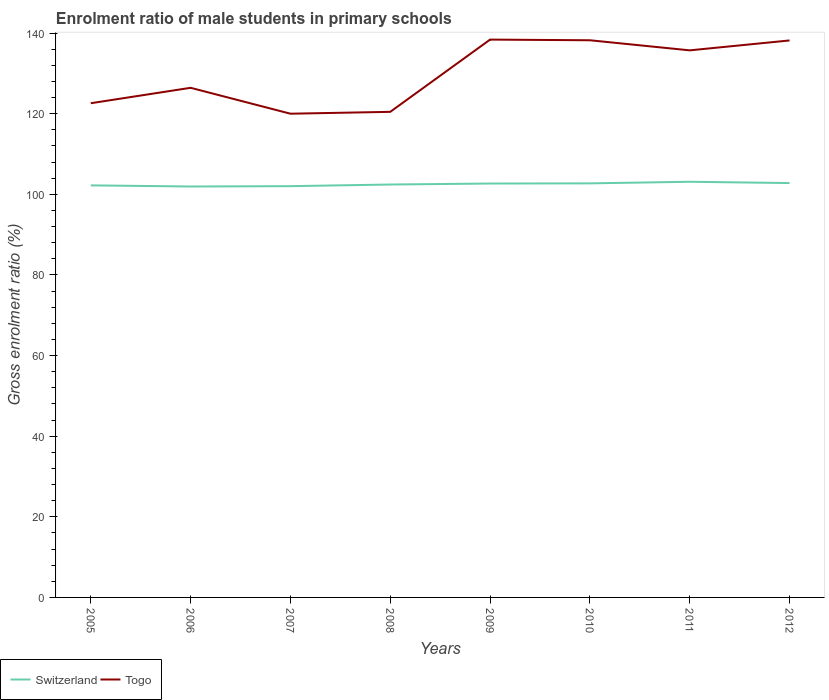How many different coloured lines are there?
Your answer should be very brief. 2. Does the line corresponding to Switzerland intersect with the line corresponding to Togo?
Your answer should be very brief. No. Across all years, what is the maximum enrolment ratio of male students in primary schools in Togo?
Your answer should be very brief. 120. What is the total enrolment ratio of male students in primary schools in Switzerland in the graph?
Make the answer very short. -0.68. What is the difference between the highest and the second highest enrolment ratio of male students in primary schools in Switzerland?
Give a very brief answer. 1.17. Is the enrolment ratio of male students in primary schools in Switzerland strictly greater than the enrolment ratio of male students in primary schools in Togo over the years?
Your answer should be compact. Yes. How many years are there in the graph?
Your answer should be compact. 8. Does the graph contain any zero values?
Your answer should be compact. No. Does the graph contain grids?
Ensure brevity in your answer.  No. How many legend labels are there?
Your answer should be very brief. 2. How are the legend labels stacked?
Give a very brief answer. Horizontal. What is the title of the graph?
Give a very brief answer. Enrolment ratio of male students in primary schools. Does "Marshall Islands" appear as one of the legend labels in the graph?
Ensure brevity in your answer.  No. What is the Gross enrolment ratio (%) of Switzerland in 2005?
Your answer should be very brief. 102.22. What is the Gross enrolment ratio (%) in Togo in 2005?
Your answer should be very brief. 122.6. What is the Gross enrolment ratio (%) of Switzerland in 2006?
Make the answer very short. 101.94. What is the Gross enrolment ratio (%) in Togo in 2006?
Offer a very short reply. 126.42. What is the Gross enrolment ratio (%) in Switzerland in 2007?
Offer a very short reply. 102.03. What is the Gross enrolment ratio (%) in Togo in 2007?
Ensure brevity in your answer.  120. What is the Gross enrolment ratio (%) in Switzerland in 2008?
Your answer should be very brief. 102.43. What is the Gross enrolment ratio (%) in Togo in 2008?
Your response must be concise. 120.46. What is the Gross enrolment ratio (%) of Switzerland in 2009?
Provide a succinct answer. 102.68. What is the Gross enrolment ratio (%) of Togo in 2009?
Keep it short and to the point. 138.38. What is the Gross enrolment ratio (%) in Switzerland in 2010?
Your response must be concise. 102.72. What is the Gross enrolment ratio (%) in Togo in 2010?
Make the answer very short. 138.22. What is the Gross enrolment ratio (%) in Switzerland in 2011?
Keep it short and to the point. 103.12. What is the Gross enrolment ratio (%) of Togo in 2011?
Make the answer very short. 135.72. What is the Gross enrolment ratio (%) of Switzerland in 2012?
Offer a terse response. 102.79. What is the Gross enrolment ratio (%) of Togo in 2012?
Provide a short and direct response. 138.17. Across all years, what is the maximum Gross enrolment ratio (%) in Switzerland?
Provide a succinct answer. 103.12. Across all years, what is the maximum Gross enrolment ratio (%) of Togo?
Give a very brief answer. 138.38. Across all years, what is the minimum Gross enrolment ratio (%) of Switzerland?
Ensure brevity in your answer.  101.94. Across all years, what is the minimum Gross enrolment ratio (%) in Togo?
Give a very brief answer. 120. What is the total Gross enrolment ratio (%) in Switzerland in the graph?
Keep it short and to the point. 819.93. What is the total Gross enrolment ratio (%) in Togo in the graph?
Keep it short and to the point. 1039.98. What is the difference between the Gross enrolment ratio (%) in Switzerland in 2005 and that in 2006?
Your answer should be compact. 0.28. What is the difference between the Gross enrolment ratio (%) in Togo in 2005 and that in 2006?
Offer a very short reply. -3.83. What is the difference between the Gross enrolment ratio (%) in Switzerland in 2005 and that in 2007?
Give a very brief answer. 0.2. What is the difference between the Gross enrolment ratio (%) of Togo in 2005 and that in 2007?
Keep it short and to the point. 2.6. What is the difference between the Gross enrolment ratio (%) in Switzerland in 2005 and that in 2008?
Ensure brevity in your answer.  -0.21. What is the difference between the Gross enrolment ratio (%) of Togo in 2005 and that in 2008?
Your answer should be very brief. 2.14. What is the difference between the Gross enrolment ratio (%) of Switzerland in 2005 and that in 2009?
Offer a terse response. -0.45. What is the difference between the Gross enrolment ratio (%) in Togo in 2005 and that in 2009?
Your response must be concise. -15.79. What is the difference between the Gross enrolment ratio (%) of Switzerland in 2005 and that in 2010?
Your answer should be compact. -0.5. What is the difference between the Gross enrolment ratio (%) in Togo in 2005 and that in 2010?
Make the answer very short. -15.62. What is the difference between the Gross enrolment ratio (%) of Switzerland in 2005 and that in 2011?
Your answer should be compact. -0.9. What is the difference between the Gross enrolment ratio (%) of Togo in 2005 and that in 2011?
Keep it short and to the point. -13.12. What is the difference between the Gross enrolment ratio (%) in Switzerland in 2005 and that in 2012?
Your answer should be compact. -0.57. What is the difference between the Gross enrolment ratio (%) in Togo in 2005 and that in 2012?
Your answer should be very brief. -15.58. What is the difference between the Gross enrolment ratio (%) in Switzerland in 2006 and that in 2007?
Keep it short and to the point. -0.08. What is the difference between the Gross enrolment ratio (%) in Togo in 2006 and that in 2007?
Provide a short and direct response. 6.42. What is the difference between the Gross enrolment ratio (%) in Switzerland in 2006 and that in 2008?
Keep it short and to the point. -0.49. What is the difference between the Gross enrolment ratio (%) of Togo in 2006 and that in 2008?
Your answer should be very brief. 5.96. What is the difference between the Gross enrolment ratio (%) of Switzerland in 2006 and that in 2009?
Provide a succinct answer. -0.73. What is the difference between the Gross enrolment ratio (%) of Togo in 2006 and that in 2009?
Keep it short and to the point. -11.96. What is the difference between the Gross enrolment ratio (%) of Switzerland in 2006 and that in 2010?
Provide a short and direct response. -0.78. What is the difference between the Gross enrolment ratio (%) in Togo in 2006 and that in 2010?
Ensure brevity in your answer.  -11.79. What is the difference between the Gross enrolment ratio (%) of Switzerland in 2006 and that in 2011?
Provide a short and direct response. -1.17. What is the difference between the Gross enrolment ratio (%) of Togo in 2006 and that in 2011?
Offer a terse response. -9.29. What is the difference between the Gross enrolment ratio (%) in Switzerland in 2006 and that in 2012?
Your answer should be very brief. -0.85. What is the difference between the Gross enrolment ratio (%) of Togo in 2006 and that in 2012?
Your answer should be very brief. -11.75. What is the difference between the Gross enrolment ratio (%) of Switzerland in 2007 and that in 2008?
Your answer should be compact. -0.41. What is the difference between the Gross enrolment ratio (%) of Togo in 2007 and that in 2008?
Ensure brevity in your answer.  -0.46. What is the difference between the Gross enrolment ratio (%) in Switzerland in 2007 and that in 2009?
Keep it short and to the point. -0.65. What is the difference between the Gross enrolment ratio (%) in Togo in 2007 and that in 2009?
Offer a very short reply. -18.38. What is the difference between the Gross enrolment ratio (%) in Switzerland in 2007 and that in 2010?
Your answer should be very brief. -0.69. What is the difference between the Gross enrolment ratio (%) of Togo in 2007 and that in 2010?
Offer a terse response. -18.22. What is the difference between the Gross enrolment ratio (%) in Switzerland in 2007 and that in 2011?
Make the answer very short. -1.09. What is the difference between the Gross enrolment ratio (%) in Togo in 2007 and that in 2011?
Ensure brevity in your answer.  -15.72. What is the difference between the Gross enrolment ratio (%) in Switzerland in 2007 and that in 2012?
Ensure brevity in your answer.  -0.77. What is the difference between the Gross enrolment ratio (%) of Togo in 2007 and that in 2012?
Offer a very short reply. -18.17. What is the difference between the Gross enrolment ratio (%) of Switzerland in 2008 and that in 2009?
Ensure brevity in your answer.  -0.24. What is the difference between the Gross enrolment ratio (%) in Togo in 2008 and that in 2009?
Provide a short and direct response. -17.92. What is the difference between the Gross enrolment ratio (%) of Switzerland in 2008 and that in 2010?
Offer a terse response. -0.29. What is the difference between the Gross enrolment ratio (%) of Togo in 2008 and that in 2010?
Your answer should be very brief. -17.76. What is the difference between the Gross enrolment ratio (%) of Switzerland in 2008 and that in 2011?
Keep it short and to the point. -0.68. What is the difference between the Gross enrolment ratio (%) in Togo in 2008 and that in 2011?
Offer a very short reply. -15.25. What is the difference between the Gross enrolment ratio (%) of Switzerland in 2008 and that in 2012?
Make the answer very short. -0.36. What is the difference between the Gross enrolment ratio (%) of Togo in 2008 and that in 2012?
Your answer should be compact. -17.71. What is the difference between the Gross enrolment ratio (%) in Switzerland in 2009 and that in 2010?
Provide a short and direct response. -0.04. What is the difference between the Gross enrolment ratio (%) in Togo in 2009 and that in 2010?
Your response must be concise. 0.17. What is the difference between the Gross enrolment ratio (%) of Switzerland in 2009 and that in 2011?
Keep it short and to the point. -0.44. What is the difference between the Gross enrolment ratio (%) of Togo in 2009 and that in 2011?
Offer a terse response. 2.67. What is the difference between the Gross enrolment ratio (%) of Switzerland in 2009 and that in 2012?
Provide a succinct answer. -0.12. What is the difference between the Gross enrolment ratio (%) in Togo in 2009 and that in 2012?
Keep it short and to the point. 0.21. What is the difference between the Gross enrolment ratio (%) in Switzerland in 2010 and that in 2011?
Offer a very short reply. -0.4. What is the difference between the Gross enrolment ratio (%) of Togo in 2010 and that in 2011?
Your answer should be compact. 2.5. What is the difference between the Gross enrolment ratio (%) of Switzerland in 2010 and that in 2012?
Your response must be concise. -0.08. What is the difference between the Gross enrolment ratio (%) in Togo in 2010 and that in 2012?
Provide a succinct answer. 0.04. What is the difference between the Gross enrolment ratio (%) in Switzerland in 2011 and that in 2012?
Keep it short and to the point. 0.32. What is the difference between the Gross enrolment ratio (%) of Togo in 2011 and that in 2012?
Your response must be concise. -2.46. What is the difference between the Gross enrolment ratio (%) of Switzerland in 2005 and the Gross enrolment ratio (%) of Togo in 2006?
Make the answer very short. -24.2. What is the difference between the Gross enrolment ratio (%) of Switzerland in 2005 and the Gross enrolment ratio (%) of Togo in 2007?
Your response must be concise. -17.78. What is the difference between the Gross enrolment ratio (%) of Switzerland in 2005 and the Gross enrolment ratio (%) of Togo in 2008?
Offer a very short reply. -18.24. What is the difference between the Gross enrolment ratio (%) of Switzerland in 2005 and the Gross enrolment ratio (%) of Togo in 2009?
Give a very brief answer. -36.16. What is the difference between the Gross enrolment ratio (%) of Switzerland in 2005 and the Gross enrolment ratio (%) of Togo in 2010?
Provide a succinct answer. -36. What is the difference between the Gross enrolment ratio (%) of Switzerland in 2005 and the Gross enrolment ratio (%) of Togo in 2011?
Make the answer very short. -33.49. What is the difference between the Gross enrolment ratio (%) in Switzerland in 2005 and the Gross enrolment ratio (%) in Togo in 2012?
Offer a very short reply. -35.95. What is the difference between the Gross enrolment ratio (%) of Switzerland in 2006 and the Gross enrolment ratio (%) of Togo in 2007?
Your answer should be very brief. -18.06. What is the difference between the Gross enrolment ratio (%) in Switzerland in 2006 and the Gross enrolment ratio (%) in Togo in 2008?
Provide a succinct answer. -18.52. What is the difference between the Gross enrolment ratio (%) of Switzerland in 2006 and the Gross enrolment ratio (%) of Togo in 2009?
Give a very brief answer. -36.44. What is the difference between the Gross enrolment ratio (%) of Switzerland in 2006 and the Gross enrolment ratio (%) of Togo in 2010?
Your response must be concise. -36.28. What is the difference between the Gross enrolment ratio (%) of Switzerland in 2006 and the Gross enrolment ratio (%) of Togo in 2011?
Keep it short and to the point. -33.77. What is the difference between the Gross enrolment ratio (%) in Switzerland in 2006 and the Gross enrolment ratio (%) in Togo in 2012?
Ensure brevity in your answer.  -36.23. What is the difference between the Gross enrolment ratio (%) in Switzerland in 2007 and the Gross enrolment ratio (%) in Togo in 2008?
Provide a succinct answer. -18.44. What is the difference between the Gross enrolment ratio (%) of Switzerland in 2007 and the Gross enrolment ratio (%) of Togo in 2009?
Provide a short and direct response. -36.36. What is the difference between the Gross enrolment ratio (%) in Switzerland in 2007 and the Gross enrolment ratio (%) in Togo in 2010?
Offer a terse response. -36.19. What is the difference between the Gross enrolment ratio (%) in Switzerland in 2007 and the Gross enrolment ratio (%) in Togo in 2011?
Provide a short and direct response. -33.69. What is the difference between the Gross enrolment ratio (%) of Switzerland in 2007 and the Gross enrolment ratio (%) of Togo in 2012?
Make the answer very short. -36.15. What is the difference between the Gross enrolment ratio (%) of Switzerland in 2008 and the Gross enrolment ratio (%) of Togo in 2009?
Offer a very short reply. -35.95. What is the difference between the Gross enrolment ratio (%) of Switzerland in 2008 and the Gross enrolment ratio (%) of Togo in 2010?
Offer a very short reply. -35.79. What is the difference between the Gross enrolment ratio (%) of Switzerland in 2008 and the Gross enrolment ratio (%) of Togo in 2011?
Offer a terse response. -33.28. What is the difference between the Gross enrolment ratio (%) in Switzerland in 2008 and the Gross enrolment ratio (%) in Togo in 2012?
Keep it short and to the point. -35.74. What is the difference between the Gross enrolment ratio (%) in Switzerland in 2009 and the Gross enrolment ratio (%) in Togo in 2010?
Ensure brevity in your answer.  -35.54. What is the difference between the Gross enrolment ratio (%) in Switzerland in 2009 and the Gross enrolment ratio (%) in Togo in 2011?
Keep it short and to the point. -33.04. What is the difference between the Gross enrolment ratio (%) of Switzerland in 2009 and the Gross enrolment ratio (%) of Togo in 2012?
Ensure brevity in your answer.  -35.5. What is the difference between the Gross enrolment ratio (%) of Switzerland in 2010 and the Gross enrolment ratio (%) of Togo in 2011?
Offer a terse response. -33. What is the difference between the Gross enrolment ratio (%) in Switzerland in 2010 and the Gross enrolment ratio (%) in Togo in 2012?
Give a very brief answer. -35.45. What is the difference between the Gross enrolment ratio (%) in Switzerland in 2011 and the Gross enrolment ratio (%) in Togo in 2012?
Offer a very short reply. -35.06. What is the average Gross enrolment ratio (%) in Switzerland per year?
Your answer should be compact. 102.49. What is the average Gross enrolment ratio (%) of Togo per year?
Your response must be concise. 130. In the year 2005, what is the difference between the Gross enrolment ratio (%) of Switzerland and Gross enrolment ratio (%) of Togo?
Keep it short and to the point. -20.38. In the year 2006, what is the difference between the Gross enrolment ratio (%) of Switzerland and Gross enrolment ratio (%) of Togo?
Offer a terse response. -24.48. In the year 2007, what is the difference between the Gross enrolment ratio (%) in Switzerland and Gross enrolment ratio (%) in Togo?
Offer a terse response. -17.97. In the year 2008, what is the difference between the Gross enrolment ratio (%) in Switzerland and Gross enrolment ratio (%) in Togo?
Provide a short and direct response. -18.03. In the year 2009, what is the difference between the Gross enrolment ratio (%) of Switzerland and Gross enrolment ratio (%) of Togo?
Give a very brief answer. -35.71. In the year 2010, what is the difference between the Gross enrolment ratio (%) of Switzerland and Gross enrolment ratio (%) of Togo?
Ensure brevity in your answer.  -35.5. In the year 2011, what is the difference between the Gross enrolment ratio (%) in Switzerland and Gross enrolment ratio (%) in Togo?
Provide a short and direct response. -32.6. In the year 2012, what is the difference between the Gross enrolment ratio (%) in Switzerland and Gross enrolment ratio (%) in Togo?
Your answer should be compact. -35.38. What is the ratio of the Gross enrolment ratio (%) in Togo in 2005 to that in 2006?
Offer a terse response. 0.97. What is the ratio of the Gross enrolment ratio (%) of Togo in 2005 to that in 2007?
Provide a succinct answer. 1.02. What is the ratio of the Gross enrolment ratio (%) of Togo in 2005 to that in 2008?
Your response must be concise. 1.02. What is the ratio of the Gross enrolment ratio (%) in Switzerland in 2005 to that in 2009?
Offer a terse response. 1. What is the ratio of the Gross enrolment ratio (%) of Togo in 2005 to that in 2009?
Your answer should be compact. 0.89. What is the ratio of the Gross enrolment ratio (%) in Togo in 2005 to that in 2010?
Make the answer very short. 0.89. What is the ratio of the Gross enrolment ratio (%) in Switzerland in 2005 to that in 2011?
Provide a short and direct response. 0.99. What is the ratio of the Gross enrolment ratio (%) of Togo in 2005 to that in 2011?
Keep it short and to the point. 0.9. What is the ratio of the Gross enrolment ratio (%) of Togo in 2005 to that in 2012?
Provide a succinct answer. 0.89. What is the ratio of the Gross enrolment ratio (%) in Switzerland in 2006 to that in 2007?
Your answer should be compact. 1. What is the ratio of the Gross enrolment ratio (%) in Togo in 2006 to that in 2007?
Provide a short and direct response. 1.05. What is the ratio of the Gross enrolment ratio (%) of Switzerland in 2006 to that in 2008?
Keep it short and to the point. 1. What is the ratio of the Gross enrolment ratio (%) of Togo in 2006 to that in 2008?
Provide a succinct answer. 1.05. What is the ratio of the Gross enrolment ratio (%) of Switzerland in 2006 to that in 2009?
Your answer should be very brief. 0.99. What is the ratio of the Gross enrolment ratio (%) in Togo in 2006 to that in 2009?
Offer a very short reply. 0.91. What is the ratio of the Gross enrolment ratio (%) in Switzerland in 2006 to that in 2010?
Offer a terse response. 0.99. What is the ratio of the Gross enrolment ratio (%) in Togo in 2006 to that in 2010?
Your answer should be very brief. 0.91. What is the ratio of the Gross enrolment ratio (%) of Togo in 2006 to that in 2011?
Offer a very short reply. 0.93. What is the ratio of the Gross enrolment ratio (%) in Switzerland in 2006 to that in 2012?
Your answer should be very brief. 0.99. What is the ratio of the Gross enrolment ratio (%) in Togo in 2006 to that in 2012?
Your answer should be very brief. 0.92. What is the ratio of the Gross enrolment ratio (%) of Switzerland in 2007 to that in 2008?
Your response must be concise. 1. What is the ratio of the Gross enrolment ratio (%) in Togo in 2007 to that in 2009?
Provide a short and direct response. 0.87. What is the ratio of the Gross enrolment ratio (%) in Switzerland in 2007 to that in 2010?
Provide a short and direct response. 0.99. What is the ratio of the Gross enrolment ratio (%) in Togo in 2007 to that in 2010?
Provide a short and direct response. 0.87. What is the ratio of the Gross enrolment ratio (%) of Togo in 2007 to that in 2011?
Provide a short and direct response. 0.88. What is the ratio of the Gross enrolment ratio (%) in Switzerland in 2007 to that in 2012?
Offer a very short reply. 0.99. What is the ratio of the Gross enrolment ratio (%) of Togo in 2007 to that in 2012?
Provide a short and direct response. 0.87. What is the ratio of the Gross enrolment ratio (%) of Togo in 2008 to that in 2009?
Offer a very short reply. 0.87. What is the ratio of the Gross enrolment ratio (%) in Togo in 2008 to that in 2010?
Your answer should be very brief. 0.87. What is the ratio of the Gross enrolment ratio (%) in Togo in 2008 to that in 2011?
Offer a very short reply. 0.89. What is the ratio of the Gross enrolment ratio (%) in Togo in 2008 to that in 2012?
Ensure brevity in your answer.  0.87. What is the ratio of the Gross enrolment ratio (%) of Switzerland in 2009 to that in 2010?
Your answer should be compact. 1. What is the ratio of the Gross enrolment ratio (%) in Switzerland in 2009 to that in 2011?
Offer a very short reply. 1. What is the ratio of the Gross enrolment ratio (%) in Togo in 2009 to that in 2011?
Your answer should be very brief. 1.02. What is the ratio of the Gross enrolment ratio (%) of Switzerland in 2010 to that in 2011?
Keep it short and to the point. 1. What is the ratio of the Gross enrolment ratio (%) in Togo in 2010 to that in 2011?
Offer a terse response. 1.02. What is the ratio of the Gross enrolment ratio (%) in Switzerland in 2010 to that in 2012?
Offer a very short reply. 1. What is the ratio of the Gross enrolment ratio (%) of Togo in 2011 to that in 2012?
Make the answer very short. 0.98. What is the difference between the highest and the second highest Gross enrolment ratio (%) of Switzerland?
Your response must be concise. 0.32. What is the difference between the highest and the second highest Gross enrolment ratio (%) of Togo?
Your answer should be compact. 0.17. What is the difference between the highest and the lowest Gross enrolment ratio (%) of Switzerland?
Offer a terse response. 1.17. What is the difference between the highest and the lowest Gross enrolment ratio (%) in Togo?
Provide a succinct answer. 18.38. 